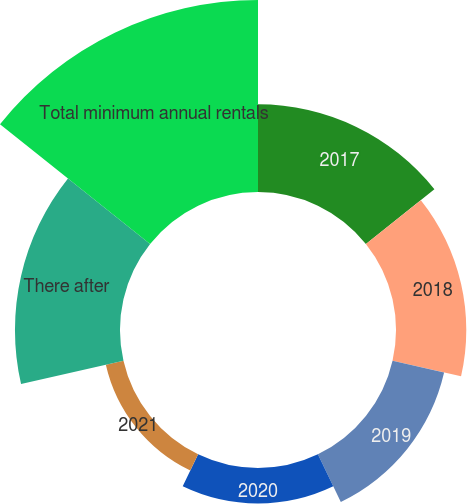<chart> <loc_0><loc_0><loc_500><loc_500><pie_chart><fcel>2017<fcel>2018<fcel>2019<fcel>2020<fcel>2021<fcel>There after<fcel>Total minimum annual rentals<nl><fcel>15.61%<fcel>12.52%<fcel>9.42%<fcel>6.32%<fcel>3.22%<fcel>18.71%<fcel>34.2%<nl></chart> 